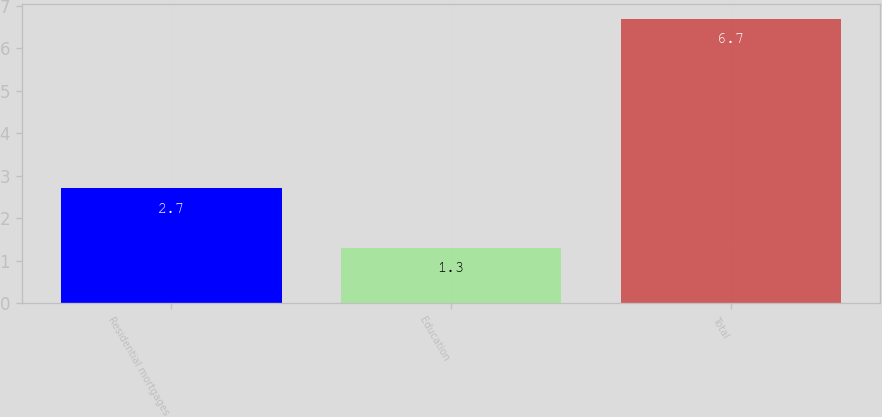Convert chart to OTSL. <chart><loc_0><loc_0><loc_500><loc_500><bar_chart><fcel>Residential mortgages<fcel>Education<fcel>Total<nl><fcel>2.7<fcel>1.3<fcel>6.7<nl></chart> 